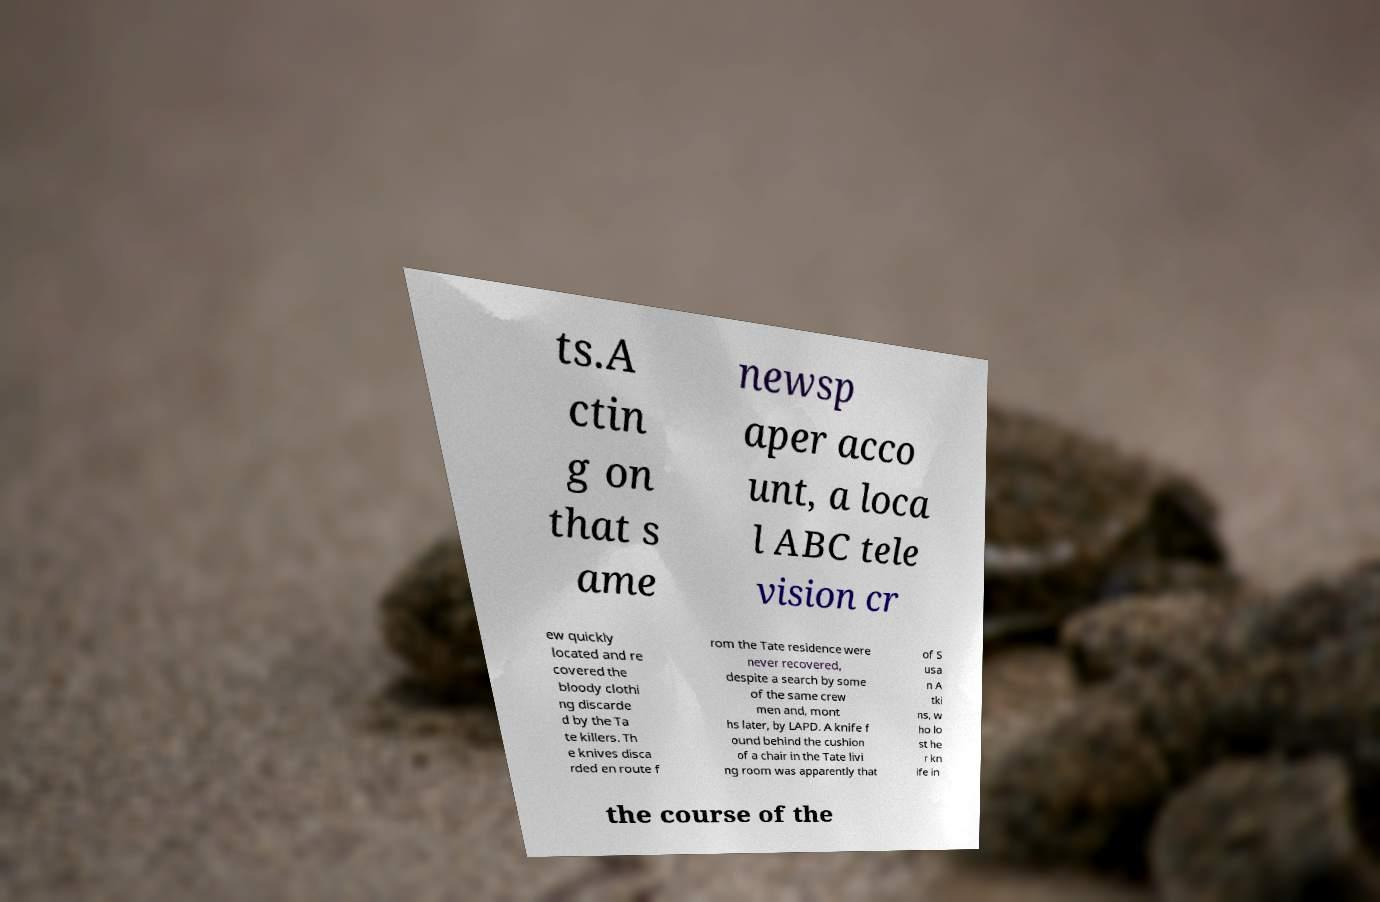There's text embedded in this image that I need extracted. Can you transcribe it verbatim? ts.A ctin g on that s ame newsp aper acco unt, a loca l ABC tele vision cr ew quickly located and re covered the bloody clothi ng discarde d by the Ta te killers. Th e knives disca rded en route f rom the Tate residence were never recovered, despite a search by some of the same crew men and, mont hs later, by LAPD. A knife f ound behind the cushion of a chair in the Tate livi ng room was apparently that of S usa n A tki ns, w ho lo st he r kn ife in the course of the 